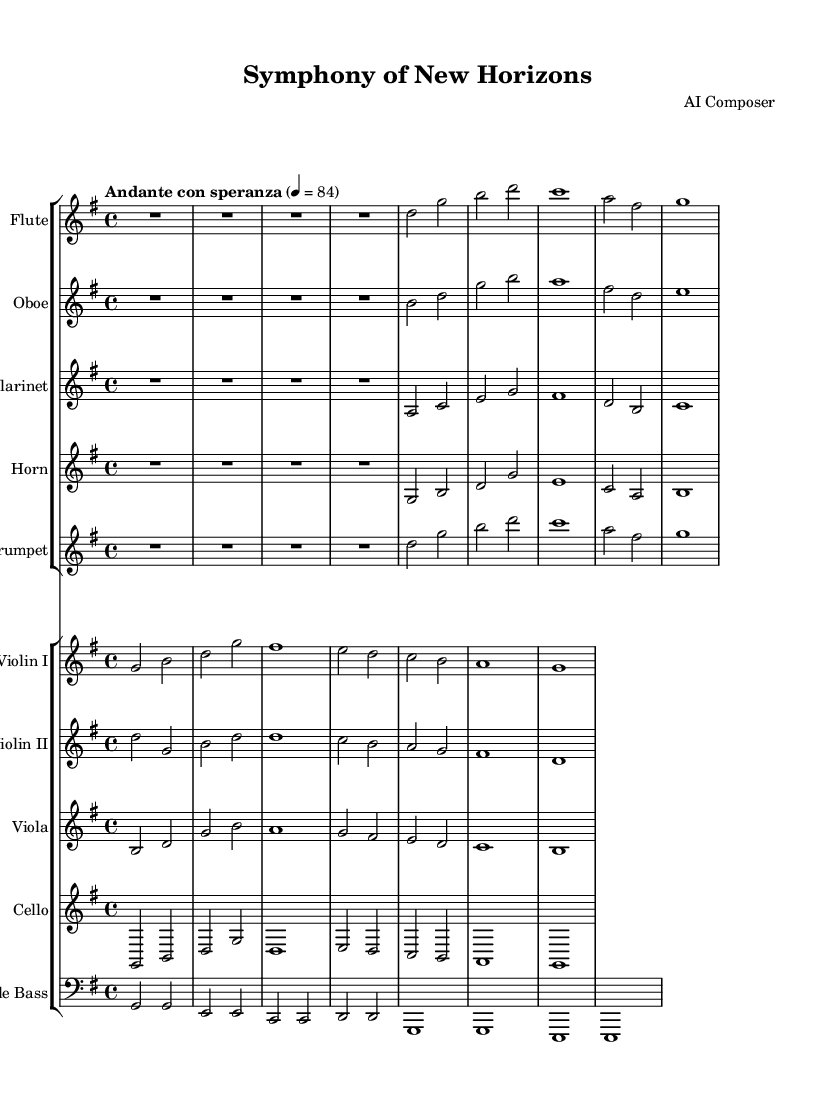What is the key signature of this music? The key signature is G major, which has one sharp (F#). This can be determined by looking at the key signature at the beginning of the first staff, which indicates the specific notes that are sharp within the scale.
Answer: G major What is the time signature of this music? The time signature is 4/4, which can be found at the beginning of the sheet music. It indicates that there are four beats in each measure and the quarter note receives one beat.
Answer: 4/4 What is the tempo marking of this piece? The tempo marking is "Andante con speranza." This is located at the beginning of the piece and indicates the intended speed and emotional character of the music, suggesting a moderately slow pace with a sense of hope.
Answer: Andante con speranza Which instruments are included in the score? The instruments included are Flute, Oboe, Clarinet, Horn, Trumpet, Violin I, Violin II, Viola, Cello, and Double Bass. This can be determined by looking at the staff groups where each instrument name is listed above its respective staff.
Answer: Flute, Oboe, Clarinet, Horn, Trumpet, Violin I, Violin II, Viola, Cello, Double Bass How many measures are in the first violin part? The first violin part has a total of 8 measures. By counting the segment divisions on the staff for the violin part, we see that each segment represents one measure and there are eight segments in total within the provided excerpt.
Answer: 8 Which instrument has the highest pitch in this score? The Flute is the highest-pitched instrument in this score. This can be analyzed by comparing the ranges of the different instruments shown in the sheet music, where the flute is played in the upper register relative to other instruments.
Answer: Flute 